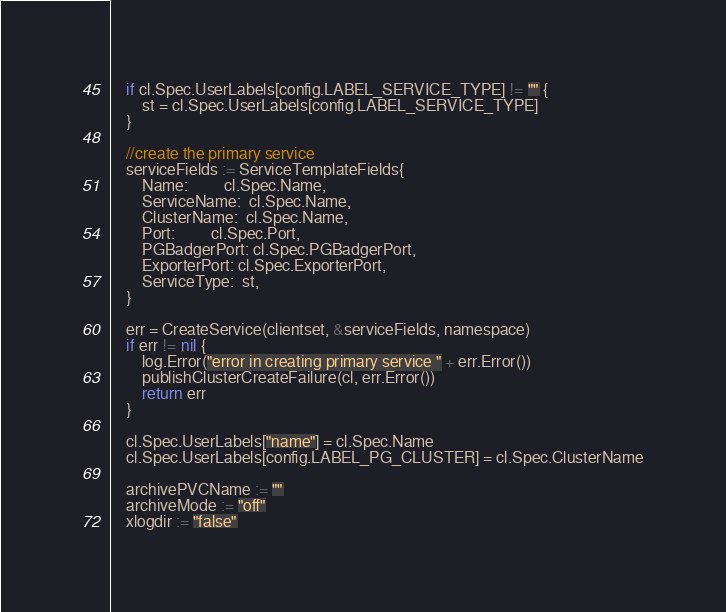<code> <loc_0><loc_0><loc_500><loc_500><_Go_>	if cl.Spec.UserLabels[config.LABEL_SERVICE_TYPE] != "" {
		st = cl.Spec.UserLabels[config.LABEL_SERVICE_TYPE]
	}

	//create the primary service
	serviceFields := ServiceTemplateFields{
		Name:         cl.Spec.Name,
		ServiceName:  cl.Spec.Name,
		ClusterName:  cl.Spec.Name,
		Port:         cl.Spec.Port,
		PGBadgerPort: cl.Spec.PGBadgerPort,
		ExporterPort: cl.Spec.ExporterPort,
		ServiceType:  st,
	}

	err = CreateService(clientset, &serviceFields, namespace)
	if err != nil {
		log.Error("error in creating primary service " + err.Error())
		publishClusterCreateFailure(cl, err.Error())
		return err
	}

	cl.Spec.UserLabels["name"] = cl.Spec.Name
	cl.Spec.UserLabels[config.LABEL_PG_CLUSTER] = cl.Spec.ClusterName

	archivePVCName := ""
	archiveMode := "off"
	xlogdir := "false"</code> 